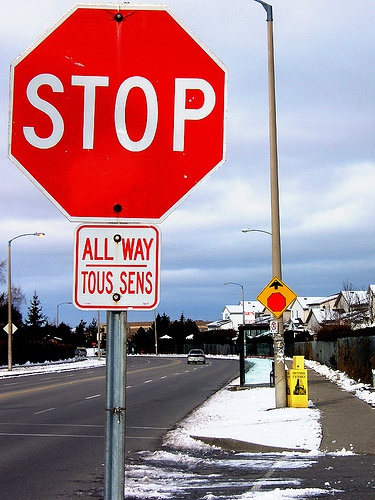Describe the objects in this image and their specific colors. I can see stop sign in lavender, red, lightgray, brown, and lightpink tones, car in lavender, black, darkgray, gray, and lightgray tones, car in lavender, black, gray, navy, and darkblue tones, and car in lavender, black, and gray tones in this image. 